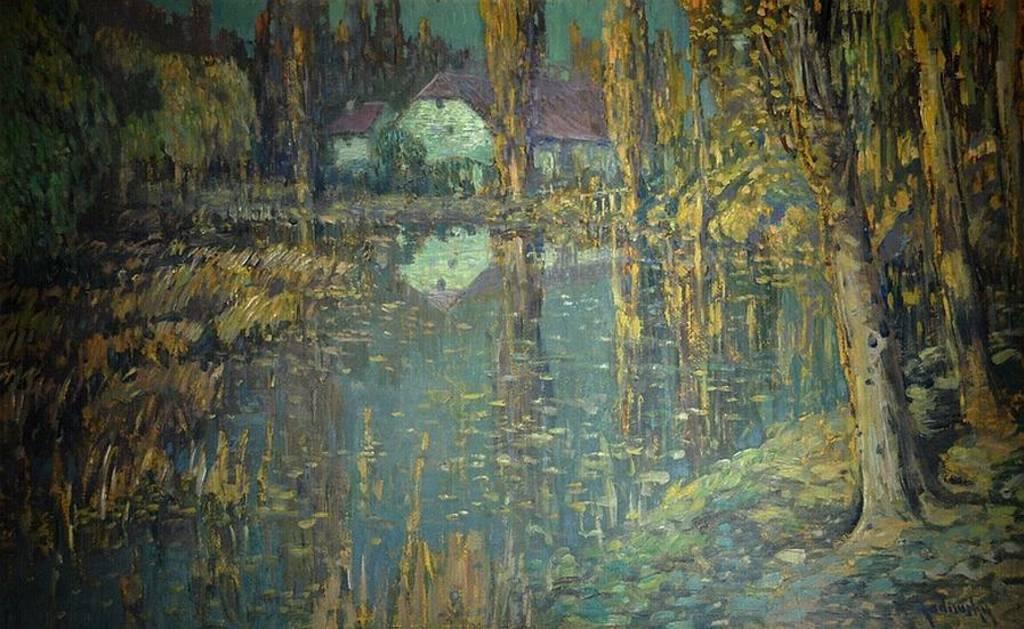Could you give a brief overview of what you see in this image? This picture shows a wall painting. We see a house, Water and trees. 